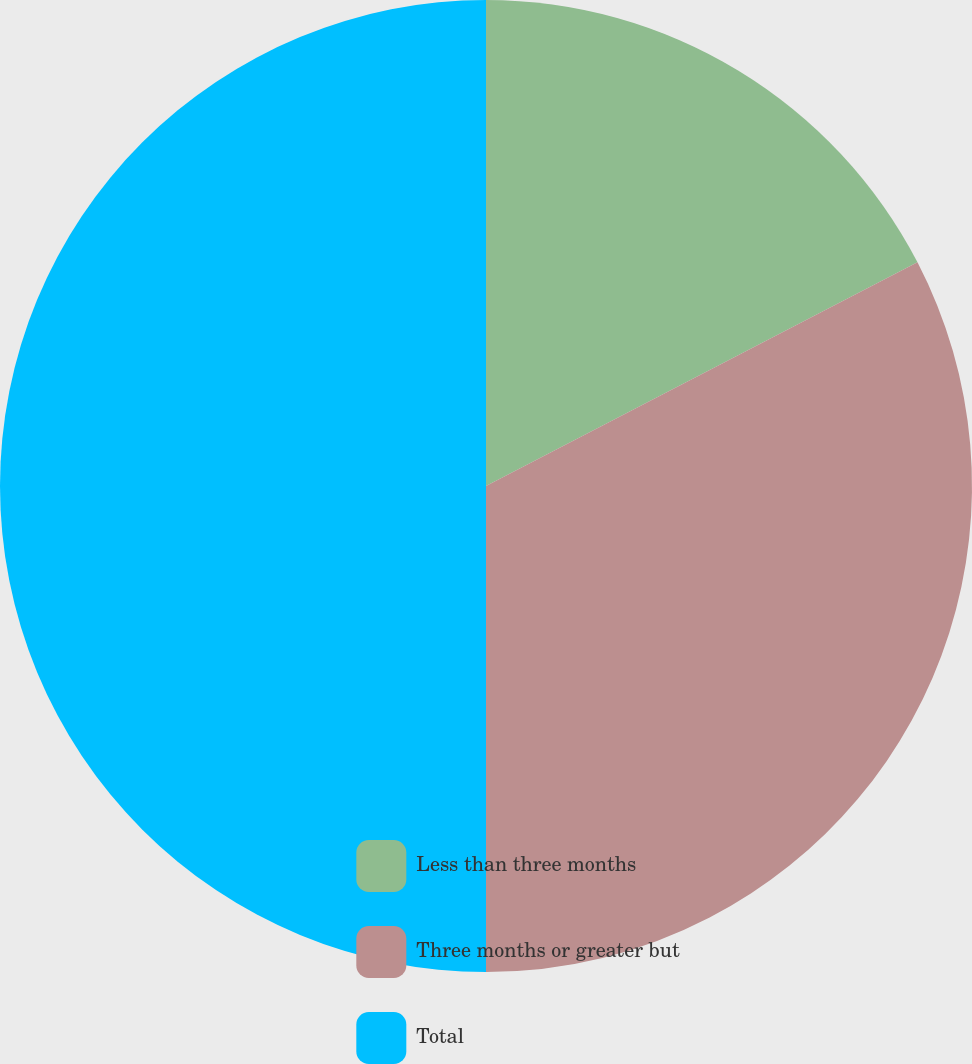Convert chart to OTSL. <chart><loc_0><loc_0><loc_500><loc_500><pie_chart><fcel>Less than three months<fcel>Three months or greater but<fcel>Total<nl><fcel>17.39%<fcel>32.61%<fcel>50.0%<nl></chart> 